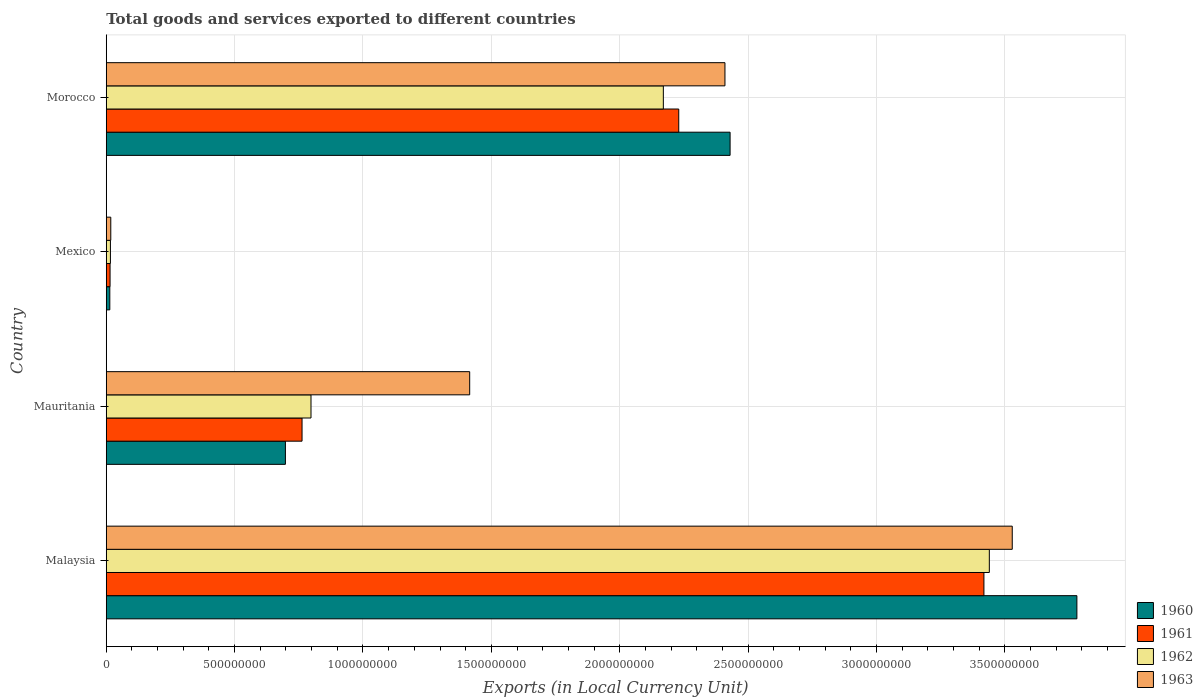Are the number of bars per tick equal to the number of legend labels?
Your answer should be compact. Yes. How many bars are there on the 4th tick from the bottom?
Your response must be concise. 4. What is the label of the 4th group of bars from the top?
Offer a terse response. Malaysia. In how many cases, is the number of bars for a given country not equal to the number of legend labels?
Provide a short and direct response. 0. What is the Amount of goods and services exports in 1960 in Mexico?
Offer a very short reply. 1.39e+07. Across all countries, what is the maximum Amount of goods and services exports in 1961?
Offer a terse response. 3.42e+09. Across all countries, what is the minimum Amount of goods and services exports in 1961?
Keep it short and to the point. 1.49e+07. In which country was the Amount of goods and services exports in 1961 maximum?
Provide a succinct answer. Malaysia. What is the total Amount of goods and services exports in 1960 in the graph?
Provide a succinct answer. 6.92e+09. What is the difference between the Amount of goods and services exports in 1961 in Malaysia and that in Morocco?
Make the answer very short. 1.19e+09. What is the difference between the Amount of goods and services exports in 1963 in Morocco and the Amount of goods and services exports in 1962 in Mauritania?
Make the answer very short. 1.61e+09. What is the average Amount of goods and services exports in 1961 per country?
Your response must be concise. 1.61e+09. What is the difference between the Amount of goods and services exports in 1961 and Amount of goods and services exports in 1962 in Mauritania?
Your response must be concise. -3.49e+07. In how many countries, is the Amount of goods and services exports in 1963 greater than 2400000000 LCU?
Offer a terse response. 2. What is the ratio of the Amount of goods and services exports in 1963 in Mauritania to that in Morocco?
Your answer should be very brief. 0.59. Is the Amount of goods and services exports in 1963 in Mauritania less than that in Mexico?
Provide a succinct answer. No. What is the difference between the highest and the second highest Amount of goods and services exports in 1961?
Your answer should be compact. 1.19e+09. What is the difference between the highest and the lowest Amount of goods and services exports in 1962?
Your answer should be very brief. 3.42e+09. Is the sum of the Amount of goods and services exports in 1960 in Mexico and Morocco greater than the maximum Amount of goods and services exports in 1963 across all countries?
Provide a succinct answer. No. Is it the case that in every country, the sum of the Amount of goods and services exports in 1960 and Amount of goods and services exports in 1963 is greater than the sum of Amount of goods and services exports in 1961 and Amount of goods and services exports in 1962?
Provide a succinct answer. No. What does the 2nd bar from the bottom in Mexico represents?
Give a very brief answer. 1961. How many bars are there?
Keep it short and to the point. 16. Are all the bars in the graph horizontal?
Ensure brevity in your answer.  Yes. Are the values on the major ticks of X-axis written in scientific E-notation?
Ensure brevity in your answer.  No. Does the graph contain any zero values?
Your answer should be compact. No. Where does the legend appear in the graph?
Provide a short and direct response. Bottom right. How many legend labels are there?
Offer a very short reply. 4. What is the title of the graph?
Your response must be concise. Total goods and services exported to different countries. What is the label or title of the X-axis?
Make the answer very short. Exports (in Local Currency Unit). What is the label or title of the Y-axis?
Keep it short and to the point. Country. What is the Exports (in Local Currency Unit) of 1960 in Malaysia?
Provide a succinct answer. 3.78e+09. What is the Exports (in Local Currency Unit) of 1961 in Malaysia?
Offer a terse response. 3.42e+09. What is the Exports (in Local Currency Unit) in 1962 in Malaysia?
Your response must be concise. 3.44e+09. What is the Exports (in Local Currency Unit) of 1963 in Malaysia?
Your answer should be compact. 3.53e+09. What is the Exports (in Local Currency Unit) in 1960 in Mauritania?
Ensure brevity in your answer.  6.98e+08. What is the Exports (in Local Currency Unit) in 1961 in Mauritania?
Offer a very short reply. 7.63e+08. What is the Exports (in Local Currency Unit) of 1962 in Mauritania?
Provide a short and direct response. 7.98e+08. What is the Exports (in Local Currency Unit) in 1963 in Mauritania?
Ensure brevity in your answer.  1.42e+09. What is the Exports (in Local Currency Unit) in 1960 in Mexico?
Your answer should be compact. 1.39e+07. What is the Exports (in Local Currency Unit) of 1961 in Mexico?
Keep it short and to the point. 1.49e+07. What is the Exports (in Local Currency Unit) in 1962 in Mexico?
Offer a very short reply. 1.63e+07. What is the Exports (in Local Currency Unit) of 1963 in Mexico?
Your answer should be very brief. 1.76e+07. What is the Exports (in Local Currency Unit) of 1960 in Morocco?
Your answer should be very brief. 2.43e+09. What is the Exports (in Local Currency Unit) of 1961 in Morocco?
Give a very brief answer. 2.23e+09. What is the Exports (in Local Currency Unit) in 1962 in Morocco?
Your answer should be compact. 2.17e+09. What is the Exports (in Local Currency Unit) in 1963 in Morocco?
Provide a short and direct response. 2.41e+09. Across all countries, what is the maximum Exports (in Local Currency Unit) of 1960?
Provide a short and direct response. 3.78e+09. Across all countries, what is the maximum Exports (in Local Currency Unit) of 1961?
Ensure brevity in your answer.  3.42e+09. Across all countries, what is the maximum Exports (in Local Currency Unit) of 1962?
Ensure brevity in your answer.  3.44e+09. Across all countries, what is the maximum Exports (in Local Currency Unit) in 1963?
Give a very brief answer. 3.53e+09. Across all countries, what is the minimum Exports (in Local Currency Unit) in 1960?
Your answer should be compact. 1.39e+07. Across all countries, what is the minimum Exports (in Local Currency Unit) in 1961?
Provide a short and direct response. 1.49e+07. Across all countries, what is the minimum Exports (in Local Currency Unit) in 1962?
Offer a very short reply. 1.63e+07. Across all countries, what is the minimum Exports (in Local Currency Unit) in 1963?
Give a very brief answer. 1.76e+07. What is the total Exports (in Local Currency Unit) of 1960 in the graph?
Make the answer very short. 6.92e+09. What is the total Exports (in Local Currency Unit) of 1961 in the graph?
Your answer should be compact. 6.43e+09. What is the total Exports (in Local Currency Unit) of 1962 in the graph?
Offer a terse response. 6.42e+09. What is the total Exports (in Local Currency Unit) in 1963 in the graph?
Make the answer very short. 7.37e+09. What is the difference between the Exports (in Local Currency Unit) in 1960 in Malaysia and that in Mauritania?
Provide a succinct answer. 3.08e+09. What is the difference between the Exports (in Local Currency Unit) in 1961 in Malaysia and that in Mauritania?
Give a very brief answer. 2.66e+09. What is the difference between the Exports (in Local Currency Unit) of 1962 in Malaysia and that in Mauritania?
Make the answer very short. 2.64e+09. What is the difference between the Exports (in Local Currency Unit) in 1963 in Malaysia and that in Mauritania?
Offer a terse response. 2.11e+09. What is the difference between the Exports (in Local Currency Unit) in 1960 in Malaysia and that in Mexico?
Give a very brief answer. 3.77e+09. What is the difference between the Exports (in Local Currency Unit) in 1961 in Malaysia and that in Mexico?
Provide a short and direct response. 3.40e+09. What is the difference between the Exports (in Local Currency Unit) of 1962 in Malaysia and that in Mexico?
Ensure brevity in your answer.  3.42e+09. What is the difference between the Exports (in Local Currency Unit) of 1963 in Malaysia and that in Mexico?
Your response must be concise. 3.51e+09. What is the difference between the Exports (in Local Currency Unit) of 1960 in Malaysia and that in Morocco?
Provide a succinct answer. 1.35e+09. What is the difference between the Exports (in Local Currency Unit) of 1961 in Malaysia and that in Morocco?
Give a very brief answer. 1.19e+09. What is the difference between the Exports (in Local Currency Unit) in 1962 in Malaysia and that in Morocco?
Your answer should be very brief. 1.27e+09. What is the difference between the Exports (in Local Currency Unit) of 1963 in Malaysia and that in Morocco?
Provide a short and direct response. 1.12e+09. What is the difference between the Exports (in Local Currency Unit) in 1960 in Mauritania and that in Mexico?
Offer a very short reply. 6.84e+08. What is the difference between the Exports (in Local Currency Unit) in 1961 in Mauritania and that in Mexico?
Offer a terse response. 7.48e+08. What is the difference between the Exports (in Local Currency Unit) of 1962 in Mauritania and that in Mexico?
Your response must be concise. 7.81e+08. What is the difference between the Exports (in Local Currency Unit) in 1963 in Mauritania and that in Mexico?
Ensure brevity in your answer.  1.40e+09. What is the difference between the Exports (in Local Currency Unit) in 1960 in Mauritania and that in Morocco?
Give a very brief answer. -1.73e+09. What is the difference between the Exports (in Local Currency Unit) in 1961 in Mauritania and that in Morocco?
Ensure brevity in your answer.  -1.47e+09. What is the difference between the Exports (in Local Currency Unit) of 1962 in Mauritania and that in Morocco?
Your response must be concise. -1.37e+09. What is the difference between the Exports (in Local Currency Unit) in 1963 in Mauritania and that in Morocco?
Give a very brief answer. -9.94e+08. What is the difference between the Exports (in Local Currency Unit) in 1960 in Mexico and that in Morocco?
Give a very brief answer. -2.42e+09. What is the difference between the Exports (in Local Currency Unit) of 1961 in Mexico and that in Morocco?
Your answer should be compact. -2.22e+09. What is the difference between the Exports (in Local Currency Unit) of 1962 in Mexico and that in Morocco?
Offer a very short reply. -2.15e+09. What is the difference between the Exports (in Local Currency Unit) in 1963 in Mexico and that in Morocco?
Your response must be concise. -2.39e+09. What is the difference between the Exports (in Local Currency Unit) in 1960 in Malaysia and the Exports (in Local Currency Unit) in 1961 in Mauritania?
Make the answer very short. 3.02e+09. What is the difference between the Exports (in Local Currency Unit) in 1960 in Malaysia and the Exports (in Local Currency Unit) in 1962 in Mauritania?
Your answer should be very brief. 2.98e+09. What is the difference between the Exports (in Local Currency Unit) of 1960 in Malaysia and the Exports (in Local Currency Unit) of 1963 in Mauritania?
Your answer should be compact. 2.37e+09. What is the difference between the Exports (in Local Currency Unit) of 1961 in Malaysia and the Exports (in Local Currency Unit) of 1962 in Mauritania?
Your answer should be very brief. 2.62e+09. What is the difference between the Exports (in Local Currency Unit) in 1961 in Malaysia and the Exports (in Local Currency Unit) in 1963 in Mauritania?
Make the answer very short. 2.00e+09. What is the difference between the Exports (in Local Currency Unit) of 1962 in Malaysia and the Exports (in Local Currency Unit) of 1963 in Mauritania?
Provide a succinct answer. 2.02e+09. What is the difference between the Exports (in Local Currency Unit) of 1960 in Malaysia and the Exports (in Local Currency Unit) of 1961 in Mexico?
Your answer should be compact. 3.77e+09. What is the difference between the Exports (in Local Currency Unit) of 1960 in Malaysia and the Exports (in Local Currency Unit) of 1962 in Mexico?
Offer a terse response. 3.76e+09. What is the difference between the Exports (in Local Currency Unit) of 1960 in Malaysia and the Exports (in Local Currency Unit) of 1963 in Mexico?
Provide a short and direct response. 3.76e+09. What is the difference between the Exports (in Local Currency Unit) of 1961 in Malaysia and the Exports (in Local Currency Unit) of 1962 in Mexico?
Provide a short and direct response. 3.40e+09. What is the difference between the Exports (in Local Currency Unit) in 1961 in Malaysia and the Exports (in Local Currency Unit) in 1963 in Mexico?
Provide a short and direct response. 3.40e+09. What is the difference between the Exports (in Local Currency Unit) of 1962 in Malaysia and the Exports (in Local Currency Unit) of 1963 in Mexico?
Provide a short and direct response. 3.42e+09. What is the difference between the Exports (in Local Currency Unit) of 1960 in Malaysia and the Exports (in Local Currency Unit) of 1961 in Morocco?
Offer a very short reply. 1.55e+09. What is the difference between the Exports (in Local Currency Unit) of 1960 in Malaysia and the Exports (in Local Currency Unit) of 1962 in Morocco?
Keep it short and to the point. 1.61e+09. What is the difference between the Exports (in Local Currency Unit) in 1960 in Malaysia and the Exports (in Local Currency Unit) in 1963 in Morocco?
Offer a terse response. 1.37e+09. What is the difference between the Exports (in Local Currency Unit) of 1961 in Malaysia and the Exports (in Local Currency Unit) of 1962 in Morocco?
Make the answer very short. 1.25e+09. What is the difference between the Exports (in Local Currency Unit) of 1961 in Malaysia and the Exports (in Local Currency Unit) of 1963 in Morocco?
Offer a terse response. 1.01e+09. What is the difference between the Exports (in Local Currency Unit) in 1962 in Malaysia and the Exports (in Local Currency Unit) in 1963 in Morocco?
Your response must be concise. 1.03e+09. What is the difference between the Exports (in Local Currency Unit) of 1960 in Mauritania and the Exports (in Local Currency Unit) of 1961 in Mexico?
Provide a short and direct response. 6.83e+08. What is the difference between the Exports (in Local Currency Unit) in 1960 in Mauritania and the Exports (in Local Currency Unit) in 1962 in Mexico?
Your response must be concise. 6.82e+08. What is the difference between the Exports (in Local Currency Unit) in 1960 in Mauritania and the Exports (in Local Currency Unit) in 1963 in Mexico?
Offer a terse response. 6.80e+08. What is the difference between the Exports (in Local Currency Unit) of 1961 in Mauritania and the Exports (in Local Currency Unit) of 1962 in Mexico?
Your answer should be very brief. 7.46e+08. What is the difference between the Exports (in Local Currency Unit) of 1961 in Mauritania and the Exports (in Local Currency Unit) of 1963 in Mexico?
Give a very brief answer. 7.45e+08. What is the difference between the Exports (in Local Currency Unit) in 1962 in Mauritania and the Exports (in Local Currency Unit) in 1963 in Mexico?
Ensure brevity in your answer.  7.80e+08. What is the difference between the Exports (in Local Currency Unit) in 1960 in Mauritania and the Exports (in Local Currency Unit) in 1961 in Morocco?
Offer a very short reply. -1.53e+09. What is the difference between the Exports (in Local Currency Unit) in 1960 in Mauritania and the Exports (in Local Currency Unit) in 1962 in Morocco?
Your answer should be very brief. -1.47e+09. What is the difference between the Exports (in Local Currency Unit) of 1960 in Mauritania and the Exports (in Local Currency Unit) of 1963 in Morocco?
Make the answer very short. -1.71e+09. What is the difference between the Exports (in Local Currency Unit) in 1961 in Mauritania and the Exports (in Local Currency Unit) in 1962 in Morocco?
Provide a short and direct response. -1.41e+09. What is the difference between the Exports (in Local Currency Unit) of 1961 in Mauritania and the Exports (in Local Currency Unit) of 1963 in Morocco?
Make the answer very short. -1.65e+09. What is the difference between the Exports (in Local Currency Unit) of 1962 in Mauritania and the Exports (in Local Currency Unit) of 1963 in Morocco?
Provide a short and direct response. -1.61e+09. What is the difference between the Exports (in Local Currency Unit) of 1960 in Mexico and the Exports (in Local Currency Unit) of 1961 in Morocco?
Your answer should be very brief. -2.22e+09. What is the difference between the Exports (in Local Currency Unit) of 1960 in Mexico and the Exports (in Local Currency Unit) of 1962 in Morocco?
Your answer should be very brief. -2.16e+09. What is the difference between the Exports (in Local Currency Unit) in 1960 in Mexico and the Exports (in Local Currency Unit) in 1963 in Morocco?
Ensure brevity in your answer.  -2.40e+09. What is the difference between the Exports (in Local Currency Unit) in 1961 in Mexico and the Exports (in Local Currency Unit) in 1962 in Morocco?
Keep it short and to the point. -2.16e+09. What is the difference between the Exports (in Local Currency Unit) of 1961 in Mexico and the Exports (in Local Currency Unit) of 1963 in Morocco?
Offer a very short reply. -2.40e+09. What is the difference between the Exports (in Local Currency Unit) in 1962 in Mexico and the Exports (in Local Currency Unit) in 1963 in Morocco?
Your answer should be very brief. -2.39e+09. What is the average Exports (in Local Currency Unit) of 1960 per country?
Give a very brief answer. 1.73e+09. What is the average Exports (in Local Currency Unit) in 1961 per country?
Offer a terse response. 1.61e+09. What is the average Exports (in Local Currency Unit) in 1962 per country?
Offer a terse response. 1.61e+09. What is the average Exports (in Local Currency Unit) in 1963 per country?
Offer a terse response. 1.84e+09. What is the difference between the Exports (in Local Currency Unit) in 1960 and Exports (in Local Currency Unit) in 1961 in Malaysia?
Your response must be concise. 3.62e+08. What is the difference between the Exports (in Local Currency Unit) in 1960 and Exports (in Local Currency Unit) in 1962 in Malaysia?
Your answer should be very brief. 3.41e+08. What is the difference between the Exports (in Local Currency Unit) of 1960 and Exports (in Local Currency Unit) of 1963 in Malaysia?
Your answer should be compact. 2.52e+08. What is the difference between the Exports (in Local Currency Unit) of 1961 and Exports (in Local Currency Unit) of 1962 in Malaysia?
Keep it short and to the point. -2.11e+07. What is the difference between the Exports (in Local Currency Unit) in 1961 and Exports (in Local Currency Unit) in 1963 in Malaysia?
Make the answer very short. -1.10e+08. What is the difference between the Exports (in Local Currency Unit) in 1962 and Exports (in Local Currency Unit) in 1963 in Malaysia?
Offer a terse response. -8.93e+07. What is the difference between the Exports (in Local Currency Unit) of 1960 and Exports (in Local Currency Unit) of 1961 in Mauritania?
Ensure brevity in your answer.  -6.48e+07. What is the difference between the Exports (in Local Currency Unit) of 1960 and Exports (in Local Currency Unit) of 1962 in Mauritania?
Make the answer very short. -9.97e+07. What is the difference between the Exports (in Local Currency Unit) of 1960 and Exports (in Local Currency Unit) of 1963 in Mauritania?
Make the answer very short. -7.18e+08. What is the difference between the Exports (in Local Currency Unit) in 1961 and Exports (in Local Currency Unit) in 1962 in Mauritania?
Offer a very short reply. -3.49e+07. What is the difference between the Exports (in Local Currency Unit) in 1961 and Exports (in Local Currency Unit) in 1963 in Mauritania?
Offer a terse response. -6.53e+08. What is the difference between the Exports (in Local Currency Unit) of 1962 and Exports (in Local Currency Unit) of 1963 in Mauritania?
Your answer should be compact. -6.18e+08. What is the difference between the Exports (in Local Currency Unit) of 1960 and Exports (in Local Currency Unit) of 1961 in Mexico?
Provide a short and direct response. -1.03e+06. What is the difference between the Exports (in Local Currency Unit) of 1960 and Exports (in Local Currency Unit) of 1962 in Mexico?
Your answer should be compact. -2.42e+06. What is the difference between the Exports (in Local Currency Unit) in 1960 and Exports (in Local Currency Unit) in 1963 in Mexico?
Ensure brevity in your answer.  -3.77e+06. What is the difference between the Exports (in Local Currency Unit) in 1961 and Exports (in Local Currency Unit) in 1962 in Mexico?
Provide a succinct answer. -1.39e+06. What is the difference between the Exports (in Local Currency Unit) of 1961 and Exports (in Local Currency Unit) of 1963 in Mexico?
Offer a very short reply. -2.75e+06. What is the difference between the Exports (in Local Currency Unit) of 1962 and Exports (in Local Currency Unit) of 1963 in Mexico?
Offer a very short reply. -1.36e+06. What is the difference between the Exports (in Local Currency Unit) in 1960 and Exports (in Local Currency Unit) in 1962 in Morocco?
Make the answer very short. 2.60e+08. What is the difference between the Exports (in Local Currency Unit) in 1960 and Exports (in Local Currency Unit) in 1963 in Morocco?
Keep it short and to the point. 2.00e+07. What is the difference between the Exports (in Local Currency Unit) of 1961 and Exports (in Local Currency Unit) of 1962 in Morocco?
Offer a very short reply. 6.00e+07. What is the difference between the Exports (in Local Currency Unit) in 1961 and Exports (in Local Currency Unit) in 1963 in Morocco?
Your answer should be compact. -1.80e+08. What is the difference between the Exports (in Local Currency Unit) of 1962 and Exports (in Local Currency Unit) of 1963 in Morocco?
Give a very brief answer. -2.40e+08. What is the ratio of the Exports (in Local Currency Unit) in 1960 in Malaysia to that in Mauritania?
Provide a succinct answer. 5.42. What is the ratio of the Exports (in Local Currency Unit) of 1961 in Malaysia to that in Mauritania?
Your answer should be compact. 4.48. What is the ratio of the Exports (in Local Currency Unit) of 1962 in Malaysia to that in Mauritania?
Keep it short and to the point. 4.31. What is the ratio of the Exports (in Local Currency Unit) in 1963 in Malaysia to that in Mauritania?
Ensure brevity in your answer.  2.49. What is the ratio of the Exports (in Local Currency Unit) in 1960 in Malaysia to that in Mexico?
Give a very brief answer. 272.71. What is the ratio of the Exports (in Local Currency Unit) of 1961 in Malaysia to that in Mexico?
Your response must be concise. 229.6. What is the ratio of the Exports (in Local Currency Unit) of 1962 in Malaysia to that in Mexico?
Give a very brief answer. 211.27. What is the ratio of the Exports (in Local Currency Unit) in 1963 in Malaysia to that in Mexico?
Your answer should be very brief. 200.08. What is the ratio of the Exports (in Local Currency Unit) of 1960 in Malaysia to that in Morocco?
Ensure brevity in your answer.  1.56. What is the ratio of the Exports (in Local Currency Unit) of 1961 in Malaysia to that in Morocco?
Provide a short and direct response. 1.53. What is the ratio of the Exports (in Local Currency Unit) of 1962 in Malaysia to that in Morocco?
Provide a succinct answer. 1.59. What is the ratio of the Exports (in Local Currency Unit) of 1963 in Malaysia to that in Morocco?
Your answer should be compact. 1.46. What is the ratio of the Exports (in Local Currency Unit) of 1960 in Mauritania to that in Mexico?
Your answer should be compact. 50.34. What is the ratio of the Exports (in Local Currency Unit) in 1961 in Mauritania to that in Mexico?
Provide a short and direct response. 51.22. What is the ratio of the Exports (in Local Currency Unit) of 1962 in Mauritania to that in Mexico?
Keep it short and to the point. 48.99. What is the ratio of the Exports (in Local Currency Unit) in 1963 in Mauritania to that in Mexico?
Your answer should be compact. 80.26. What is the ratio of the Exports (in Local Currency Unit) of 1960 in Mauritania to that in Morocco?
Your answer should be compact. 0.29. What is the ratio of the Exports (in Local Currency Unit) of 1961 in Mauritania to that in Morocco?
Your answer should be very brief. 0.34. What is the ratio of the Exports (in Local Currency Unit) of 1962 in Mauritania to that in Morocco?
Offer a very short reply. 0.37. What is the ratio of the Exports (in Local Currency Unit) in 1963 in Mauritania to that in Morocco?
Provide a short and direct response. 0.59. What is the ratio of the Exports (in Local Currency Unit) of 1960 in Mexico to that in Morocco?
Your answer should be compact. 0.01. What is the ratio of the Exports (in Local Currency Unit) in 1961 in Mexico to that in Morocco?
Provide a short and direct response. 0.01. What is the ratio of the Exports (in Local Currency Unit) of 1962 in Mexico to that in Morocco?
Offer a very short reply. 0.01. What is the ratio of the Exports (in Local Currency Unit) in 1963 in Mexico to that in Morocco?
Your answer should be compact. 0.01. What is the difference between the highest and the second highest Exports (in Local Currency Unit) of 1960?
Give a very brief answer. 1.35e+09. What is the difference between the highest and the second highest Exports (in Local Currency Unit) of 1961?
Provide a succinct answer. 1.19e+09. What is the difference between the highest and the second highest Exports (in Local Currency Unit) of 1962?
Offer a very short reply. 1.27e+09. What is the difference between the highest and the second highest Exports (in Local Currency Unit) of 1963?
Ensure brevity in your answer.  1.12e+09. What is the difference between the highest and the lowest Exports (in Local Currency Unit) in 1960?
Provide a succinct answer. 3.77e+09. What is the difference between the highest and the lowest Exports (in Local Currency Unit) of 1961?
Offer a terse response. 3.40e+09. What is the difference between the highest and the lowest Exports (in Local Currency Unit) in 1962?
Your answer should be very brief. 3.42e+09. What is the difference between the highest and the lowest Exports (in Local Currency Unit) of 1963?
Your answer should be compact. 3.51e+09. 